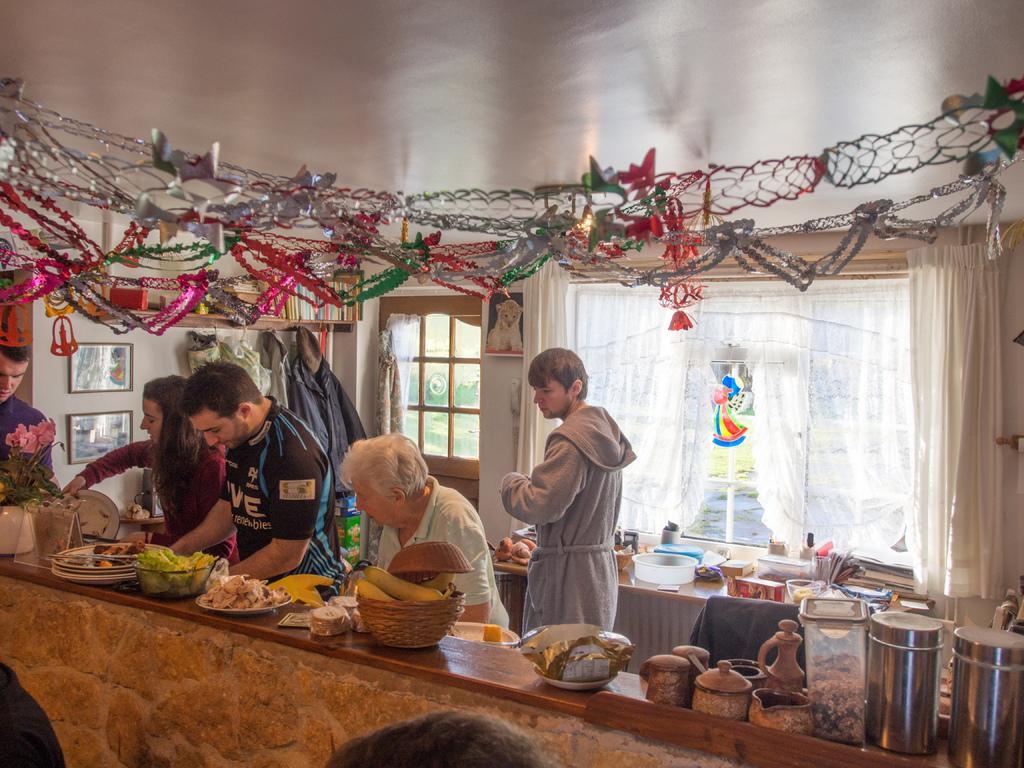Please provide a concise description of this image. In this image we can see group of persons standing at the countertop. On the counter top we can see food, baskets, plates, containers, flower vase. In the background we can see door, window, curtain, countertop, spatulas, clothes, person and photo frames. At the top of the image we can see decors. At the bottom there is a person's head. 